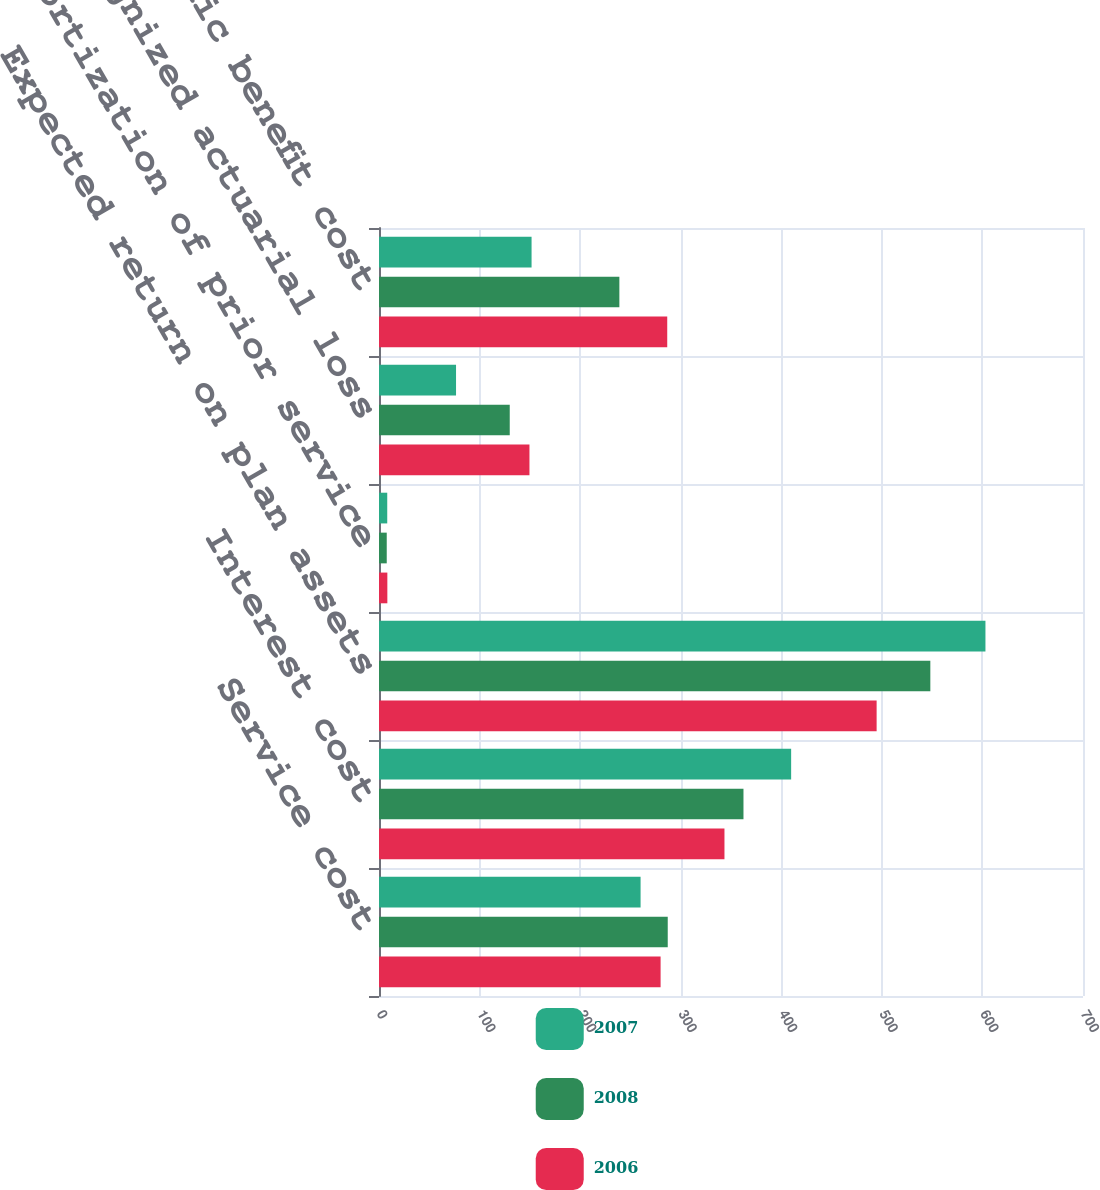Convert chart to OTSL. <chart><loc_0><loc_0><loc_500><loc_500><stacked_bar_chart><ecel><fcel>Service cost<fcel>Interest cost<fcel>Expected return on plan assets<fcel>Amortization of prior service<fcel>Recognized actuarial loss<fcel>Net periodic benefit cost<nl><fcel>2007<fcel>260.1<fcel>409.8<fcel>603<fcel>8.2<fcel>76.6<fcel>151.7<nl><fcel>2008<fcel>287.1<fcel>362.4<fcel>548.2<fcel>7.7<fcel>130<fcel>239<nl><fcel>2006<fcel>280<fcel>343.5<fcel>494.8<fcel>8.3<fcel>149.6<fcel>286.6<nl></chart> 